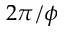<formula> <loc_0><loc_0><loc_500><loc_500>2 \pi / \phi</formula> 